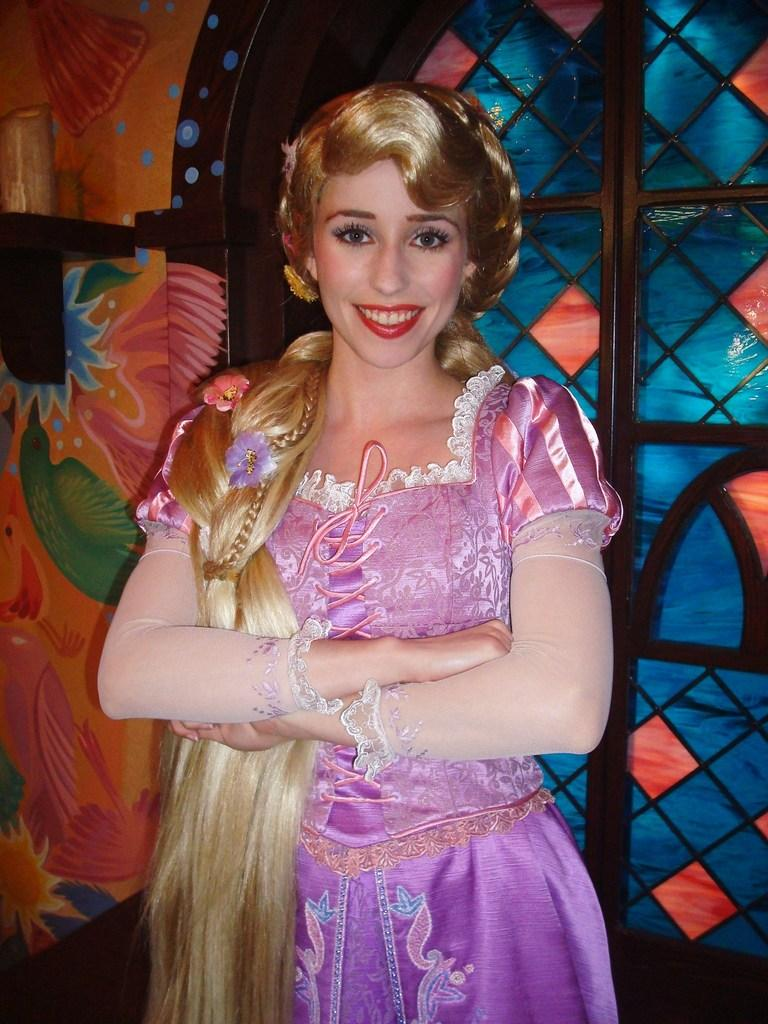Who is the main subject in the image? There is a woman in the image. What is the woman wearing? The woman is wearing a gown. What expression does the woman have? The woman is smiling. What can be seen in the background of the image? There is a colorful entrance gate in the background of the image. What is the woman's tendency to wear summer clothing in the image? The provided facts do not mention the season or the temperature, so it cannot be determined if the woman's gown is considered summer clothing. 